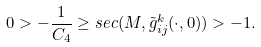<formula> <loc_0><loc_0><loc_500><loc_500>0 > - \frac { 1 } { C _ { 4 } } \geq s e c ( M , \tilde { g } _ { i j } ^ { k } ( \cdot , 0 ) ) > - 1 .</formula> 